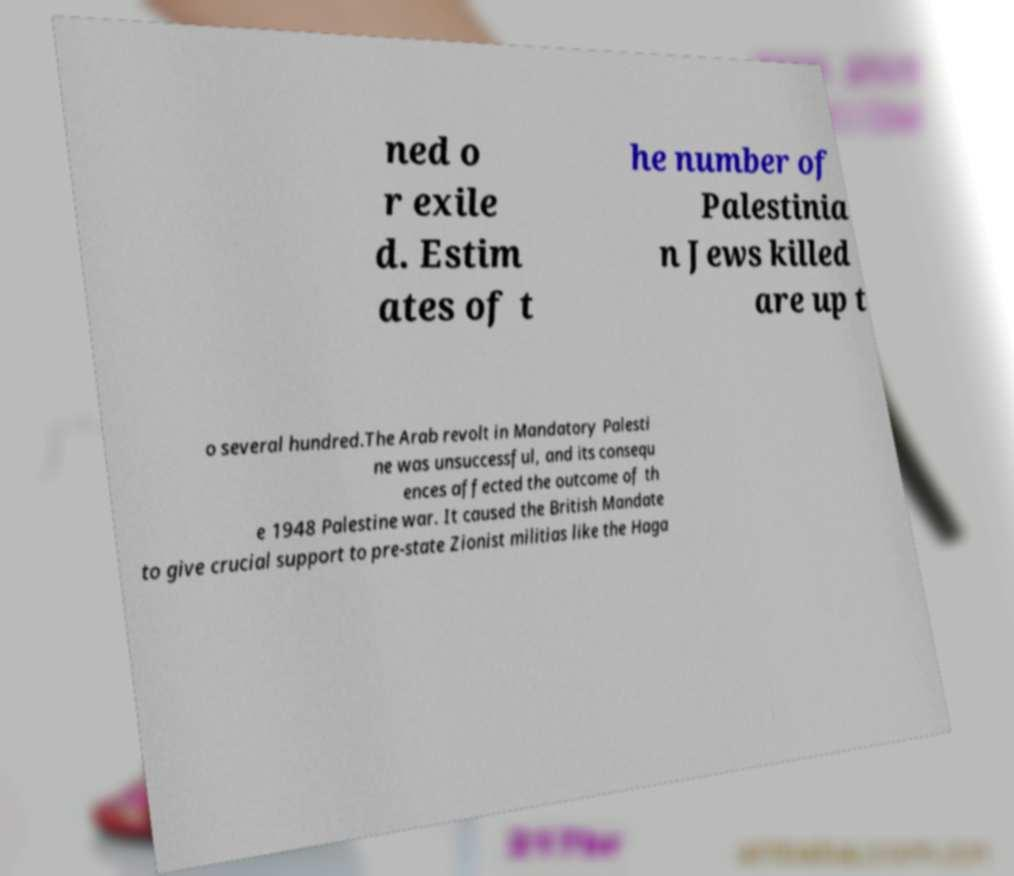I need the written content from this picture converted into text. Can you do that? ned o r exile d. Estim ates of t he number of Palestinia n Jews killed are up t o several hundred.The Arab revolt in Mandatory Palesti ne was unsuccessful, and its consequ ences affected the outcome of th e 1948 Palestine war. It caused the British Mandate to give crucial support to pre-state Zionist militias like the Haga 